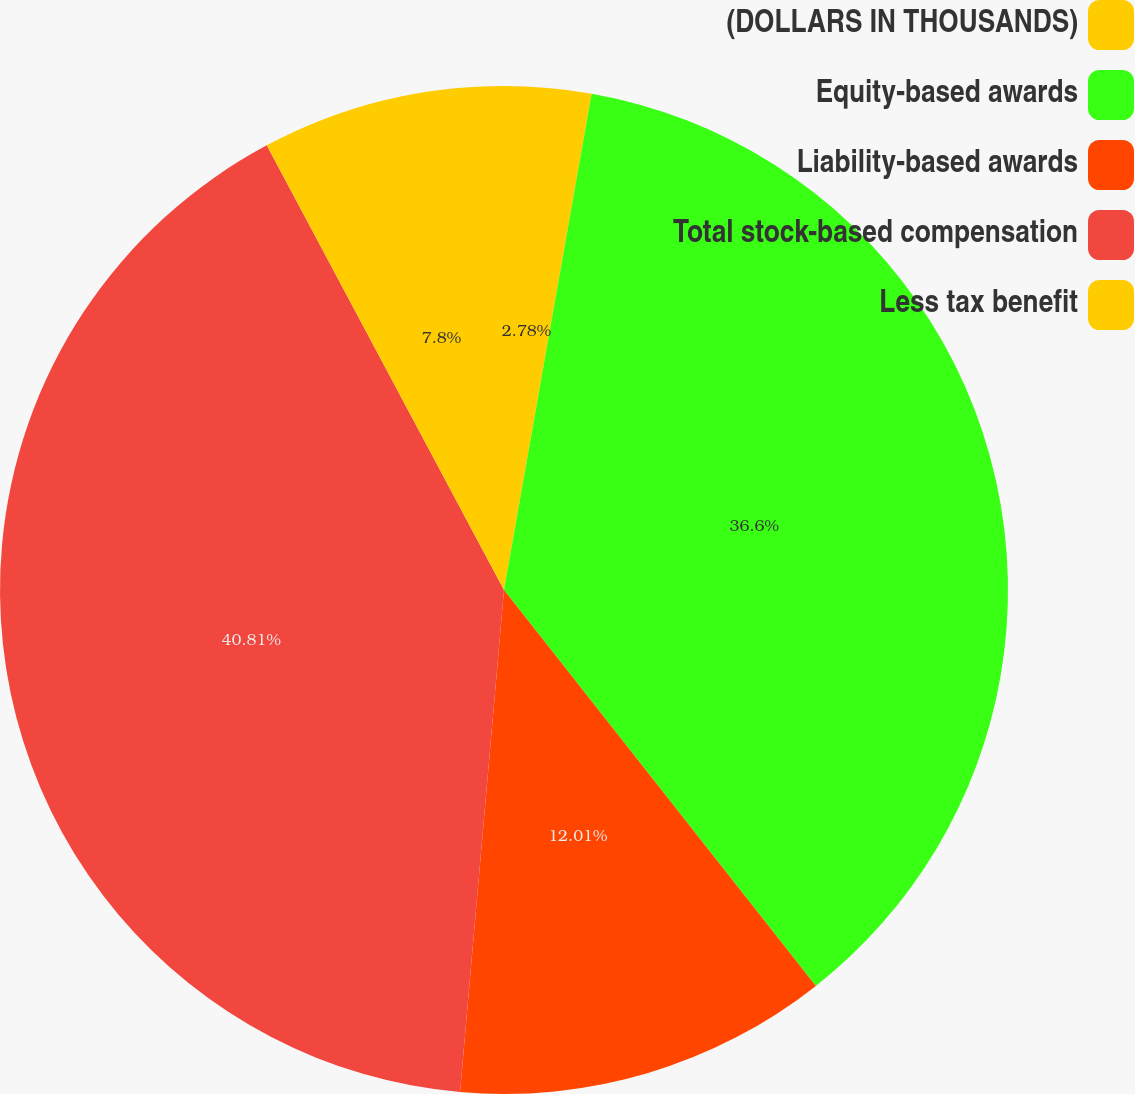Convert chart to OTSL. <chart><loc_0><loc_0><loc_500><loc_500><pie_chart><fcel>(DOLLARS IN THOUSANDS)<fcel>Equity-based awards<fcel>Liability-based awards<fcel>Total stock-based compensation<fcel>Less tax benefit<nl><fcel>2.78%<fcel>36.6%<fcel>12.01%<fcel>40.81%<fcel>7.8%<nl></chart> 